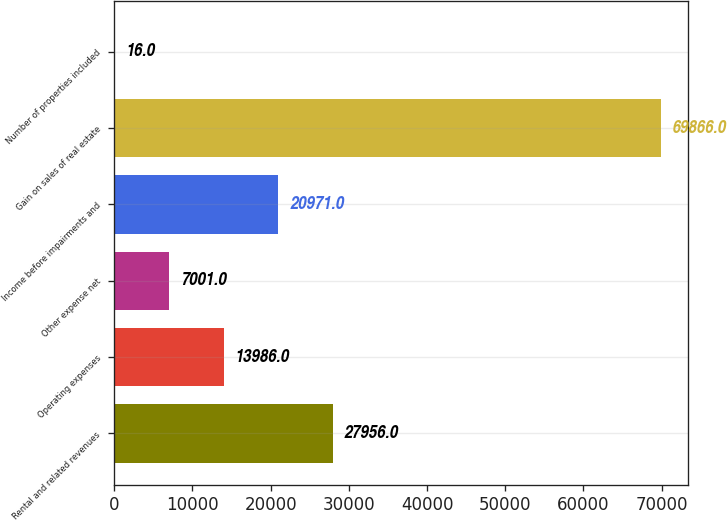<chart> <loc_0><loc_0><loc_500><loc_500><bar_chart><fcel>Rental and related revenues<fcel>Operating expenses<fcel>Other expense net<fcel>Income before impairments and<fcel>Gain on sales of real estate<fcel>Number of properties included<nl><fcel>27956<fcel>13986<fcel>7001<fcel>20971<fcel>69866<fcel>16<nl></chart> 